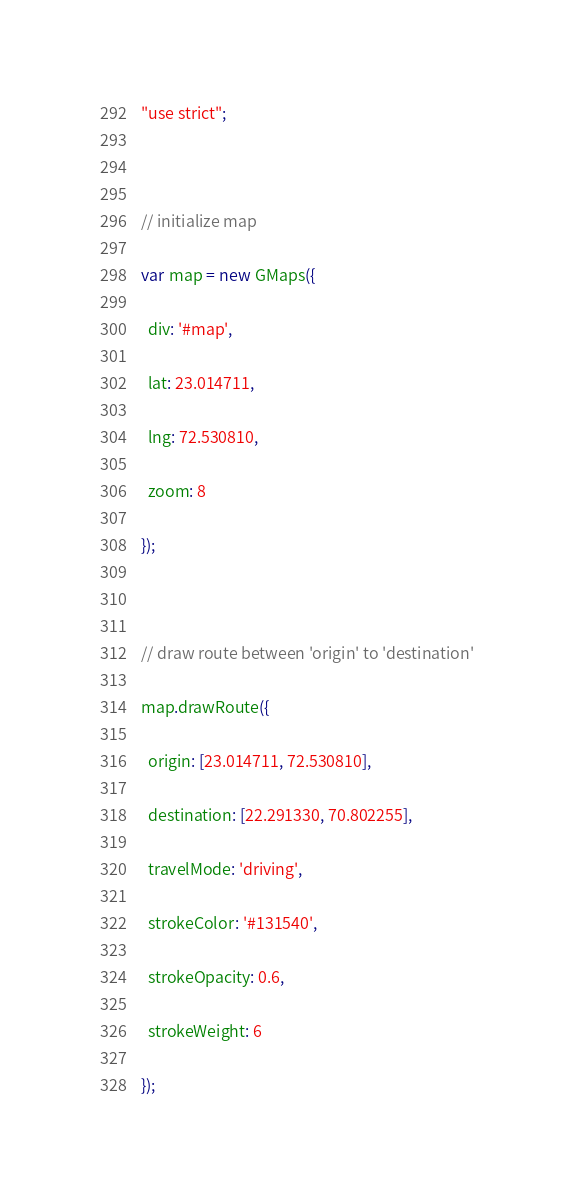<code> <loc_0><loc_0><loc_500><loc_500><_JavaScript_>"use strict";

// initialize map
var map = new GMaps({
  div: '#map',
  lat: 23.014711,
  lng: 72.530810,
  zoom: 8
});

// draw route between 'origin' to 'destination'
map.drawRoute({
  origin: [23.014711, 72.530810],
  destination: [22.291330, 70.802255],
  travelMode: 'driving',
  strokeColor: '#131540',
  strokeOpacity: 0.6,
  strokeWeight: 6
});</code> 